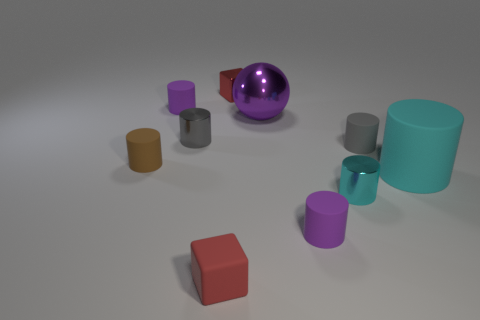There is a cyan rubber thing that is the same shape as the small gray rubber object; what is its size?
Make the answer very short. Large. What material is the tiny red cube that is in front of the purple thing in front of the tiny gray rubber cylinder?
Keep it short and to the point. Rubber. Does the tiny red matte thing have the same shape as the red metal object?
Provide a succinct answer. Yes. What number of things are both in front of the sphere and left of the big cyan matte cylinder?
Make the answer very short. 6. Are there the same number of tiny metallic cylinders that are to the right of the big rubber cylinder and big cyan cylinders in front of the small gray shiny cylinder?
Make the answer very short. No. Is the size of the purple matte cylinder to the right of the small gray metal cylinder the same as the ball that is behind the small brown matte cylinder?
Your answer should be compact. No. There is a cylinder that is behind the cyan matte cylinder and on the right side of the large purple thing; what is its material?
Provide a succinct answer. Rubber. Are there fewer big brown objects than small gray shiny things?
Your answer should be compact. Yes. What size is the ball that is to the right of the tiny gray metallic object that is behind the cyan matte cylinder?
Offer a terse response. Large. The metal object that is left of the red cube that is in front of the tiny purple matte cylinder behind the tiny cyan metal cylinder is what shape?
Ensure brevity in your answer.  Cylinder. 